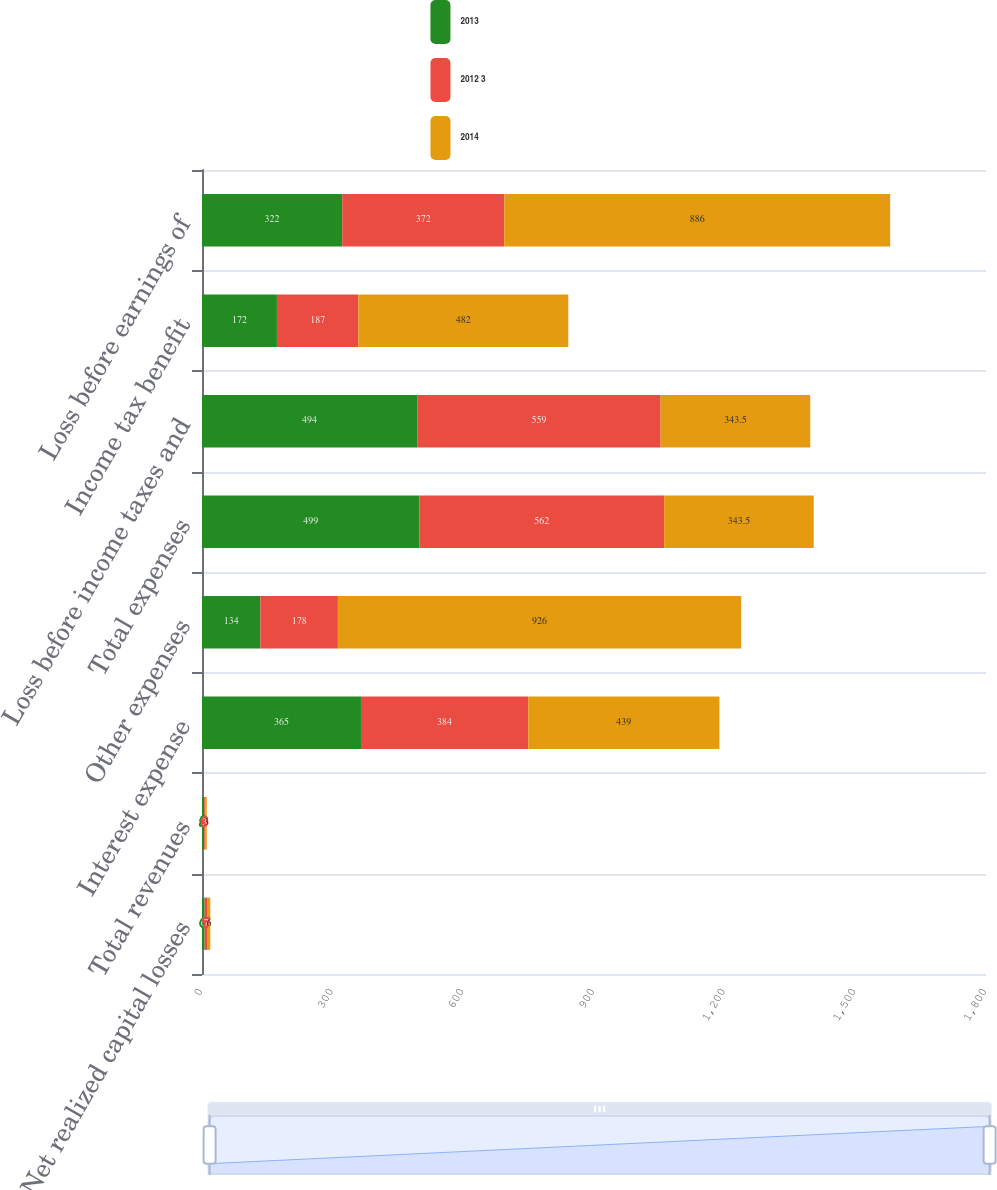Convert chart to OTSL. <chart><loc_0><loc_0><loc_500><loc_500><stacked_bar_chart><ecel><fcel>Net realized capital losses<fcel>Total revenues<fcel>Interest expense<fcel>Other expenses<fcel>Total expenses<fcel>Loss before income taxes and<fcel>Income tax benefit<fcel>Loss before earnings of<nl><fcel>2013<fcel>6<fcel>5<fcel>365<fcel>134<fcel>499<fcel>494<fcel>172<fcel>322<nl><fcel>2012 3<fcel>7<fcel>3<fcel>384<fcel>178<fcel>562<fcel>559<fcel>187<fcel>372<nl><fcel>2014<fcel>6<fcel>3<fcel>439<fcel>926<fcel>343.5<fcel>343.5<fcel>482<fcel>886<nl></chart> 